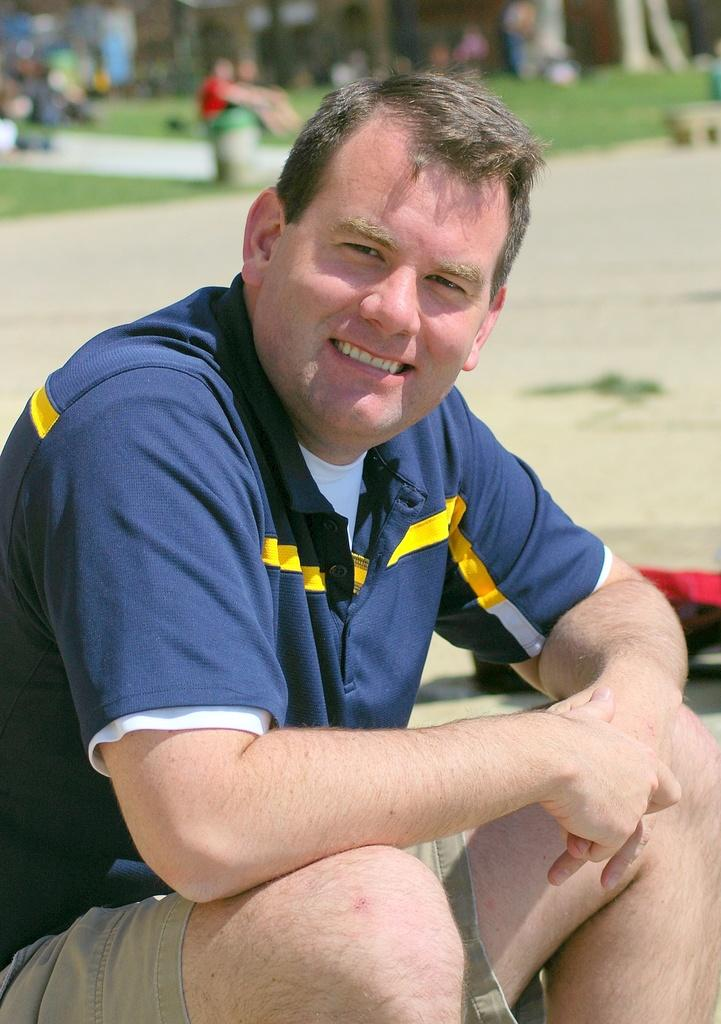What is the main subject of the image? There is a man in the image. What is the man doing in the image? The man is sitting. What is the man's facial expression in the image? The man is smiling. What can be seen in the background of the image? There is a group of people and grass in the background of the image. What time of day is the attraction featured in the image? There is no attraction mentioned or visible in the image. 